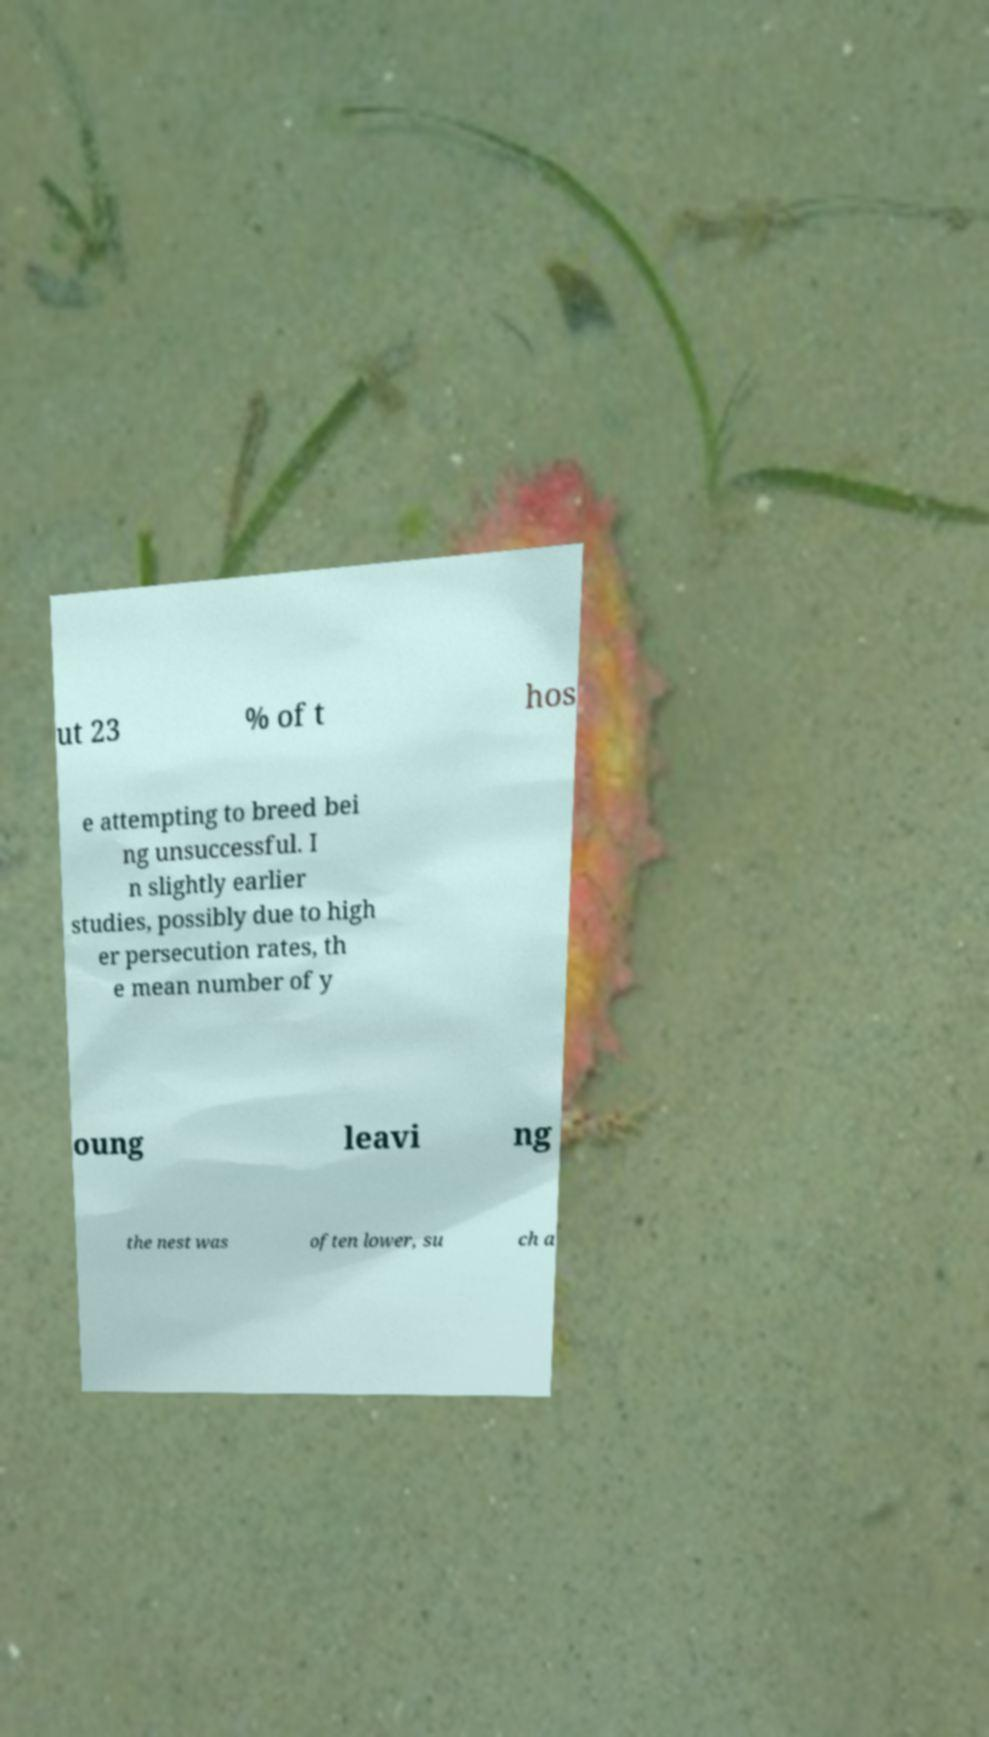Could you extract and type out the text from this image? ut 23 % of t hos e attempting to breed bei ng unsuccessful. I n slightly earlier studies, possibly due to high er persecution rates, th e mean number of y oung leavi ng the nest was often lower, su ch a 